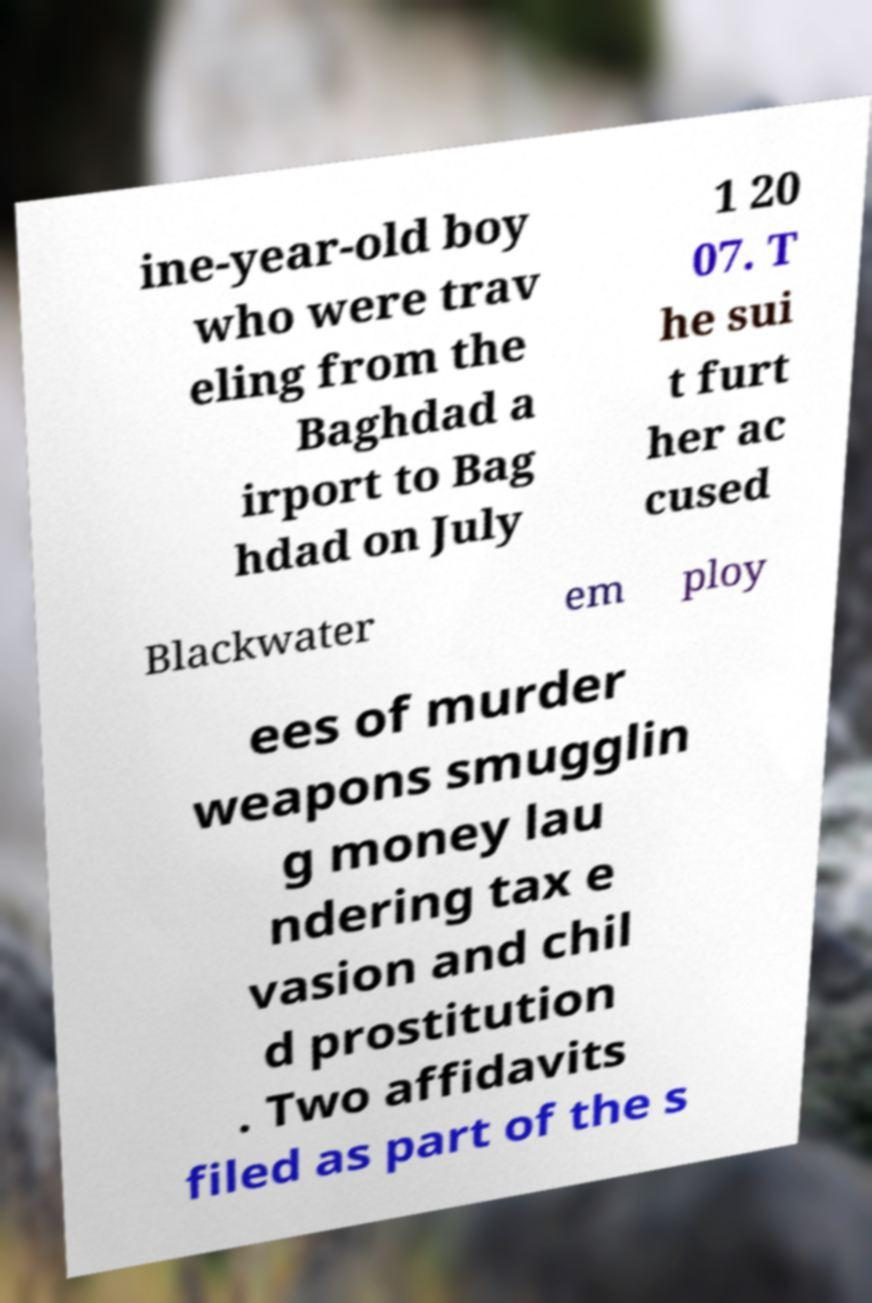I need the written content from this picture converted into text. Can you do that? ine-year-old boy who were trav eling from the Baghdad a irport to Bag hdad on July 1 20 07. T he sui t furt her ac cused Blackwater em ploy ees of murder weapons smugglin g money lau ndering tax e vasion and chil d prostitution . Two affidavits filed as part of the s 